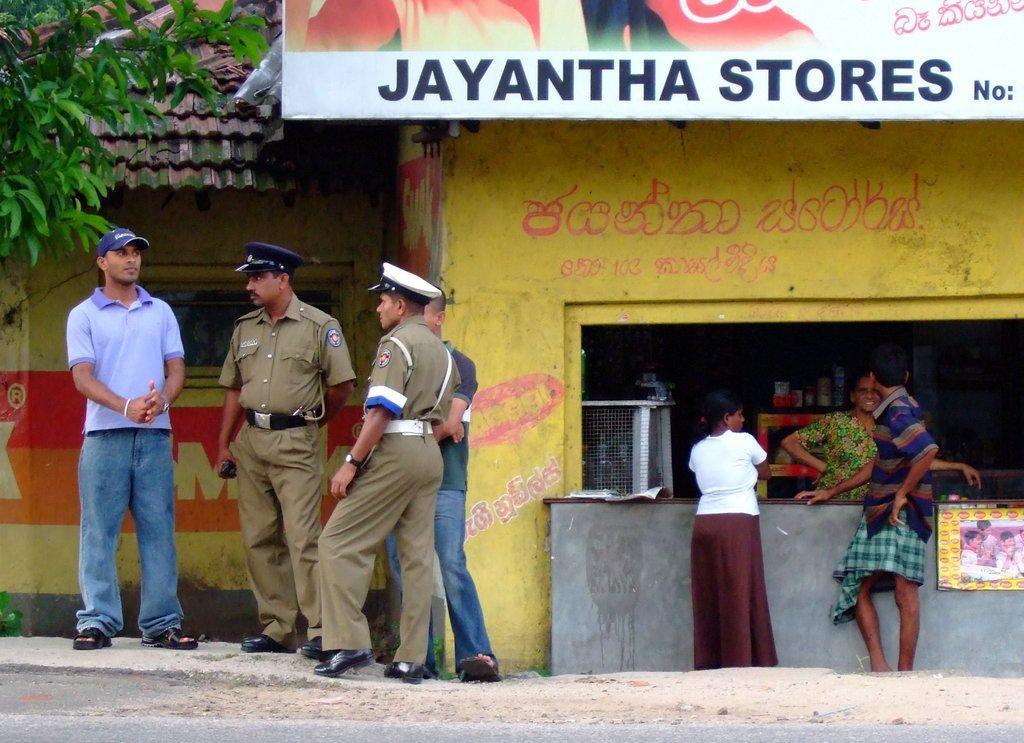Could you give a brief overview of what you see in this image? In this image we can see few people, there is a house, a tree, there is a poster with some images and text on it, there is a board with text on it, also on the wall, we can see the text. 